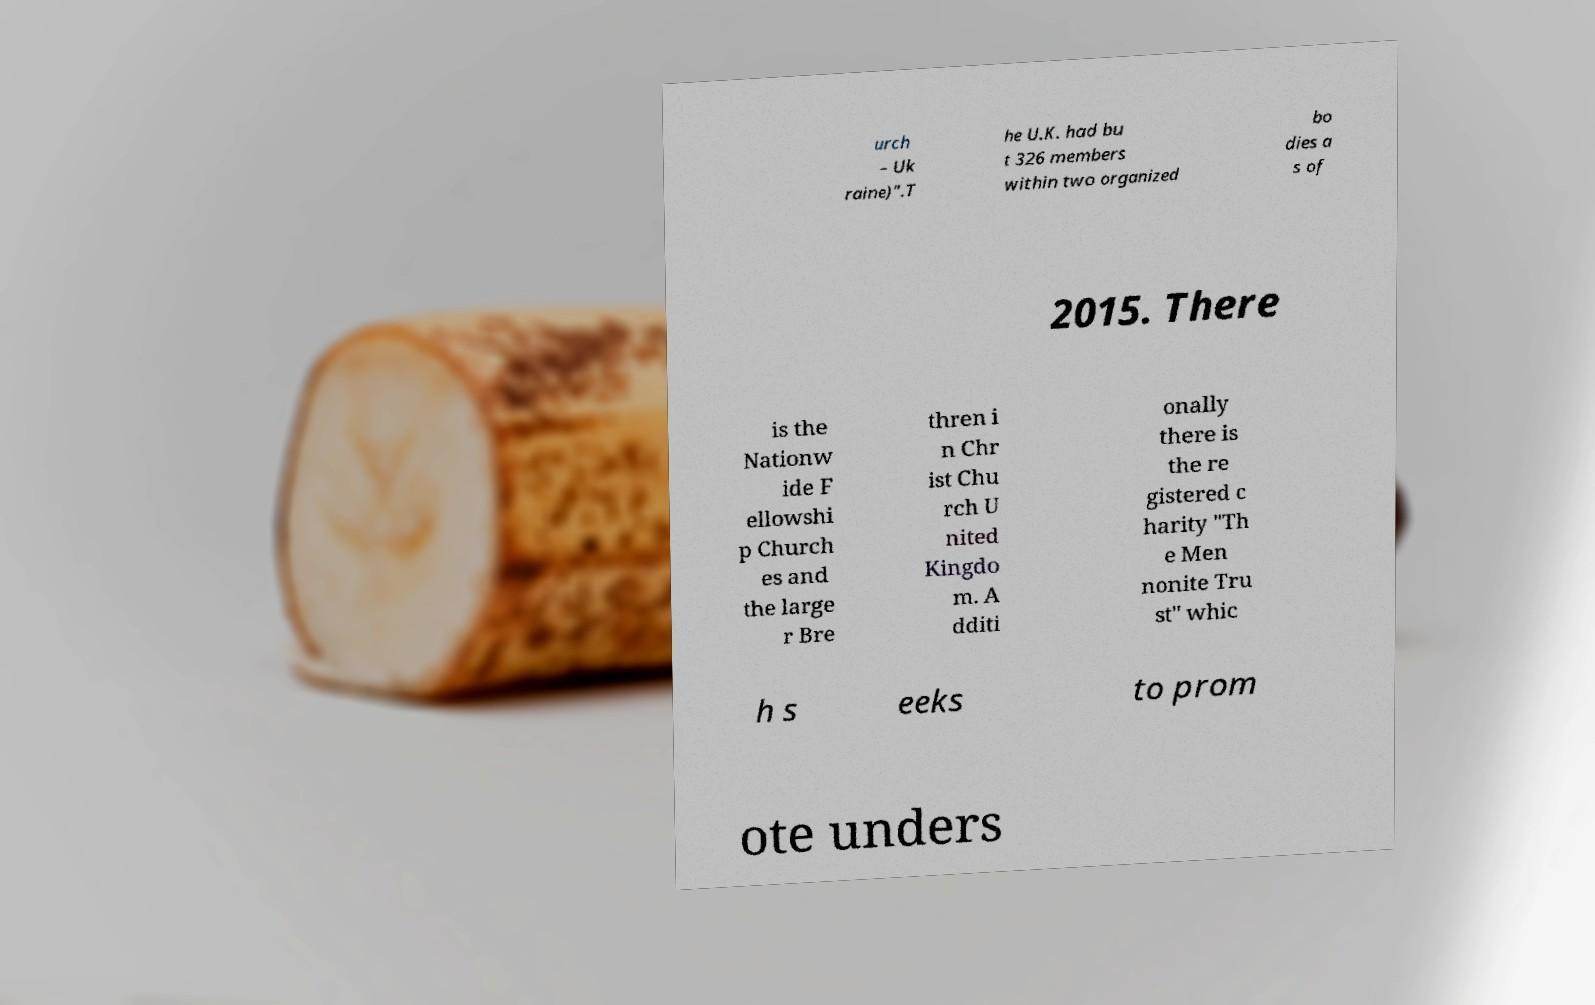Can you accurately transcribe the text from the provided image for me? urch – Uk raine)".T he U.K. had bu t 326 members within two organized bo dies a s of 2015. There is the Nationw ide F ellowshi p Church es and the large r Bre thren i n Chr ist Chu rch U nited Kingdo m. A dditi onally there is the re gistered c harity "Th e Men nonite Tru st" whic h s eeks to prom ote unders 